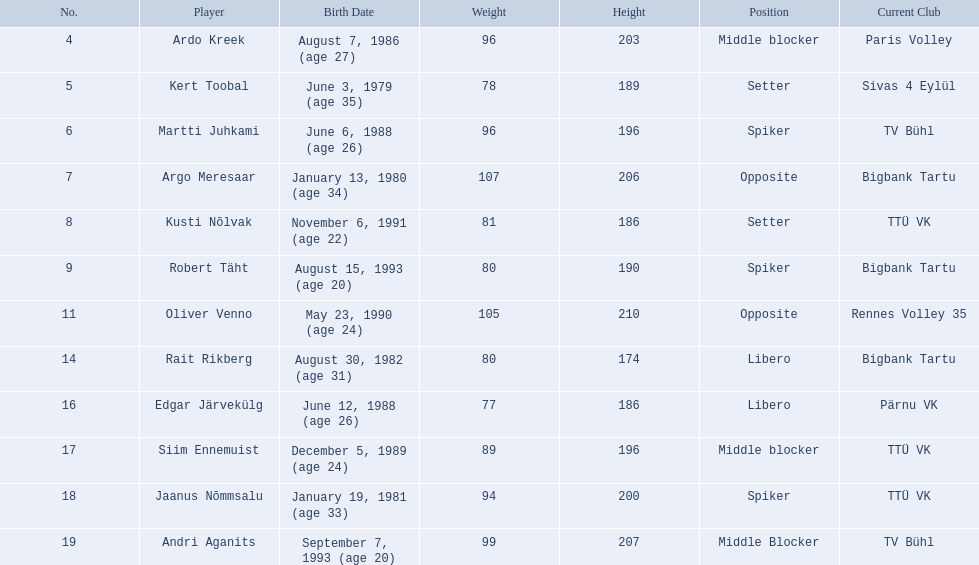Who are all the participants? Ardo Kreek, Kert Toobal, Martti Juhkami, Argo Meresaar, Kusti Nõlvak, Robert Täht, Oliver Venno, Rait Rikberg, Edgar Järvekülg, Siim Ennemuist, Jaanus Nõmmsalu, Andri Aganits. How high are they? 203, 189, 196, 206, 186, 190, 210, 174, 186, 196, 200, 207. And which participant is the highest? Oliver Venno. Can you provide the names of the players on the estonian men's national volleyball team? Ardo Kreek, Kert Toobal, Martti Juhkami, Argo Meresaar, Kusti Nõlvak, Robert Täht, Oliver Venno, Rait Rikberg, Edgar Järvekülg, Siim Ennemuist, Jaanus Nõmmsalu, Andri Aganits. Which of them are taller than 200 cm? Ardo Kreek, Argo Meresaar, Oliver Venno, Andri Aganits. Out of the players who aren't, who has the greatest height? Oliver Venno. 